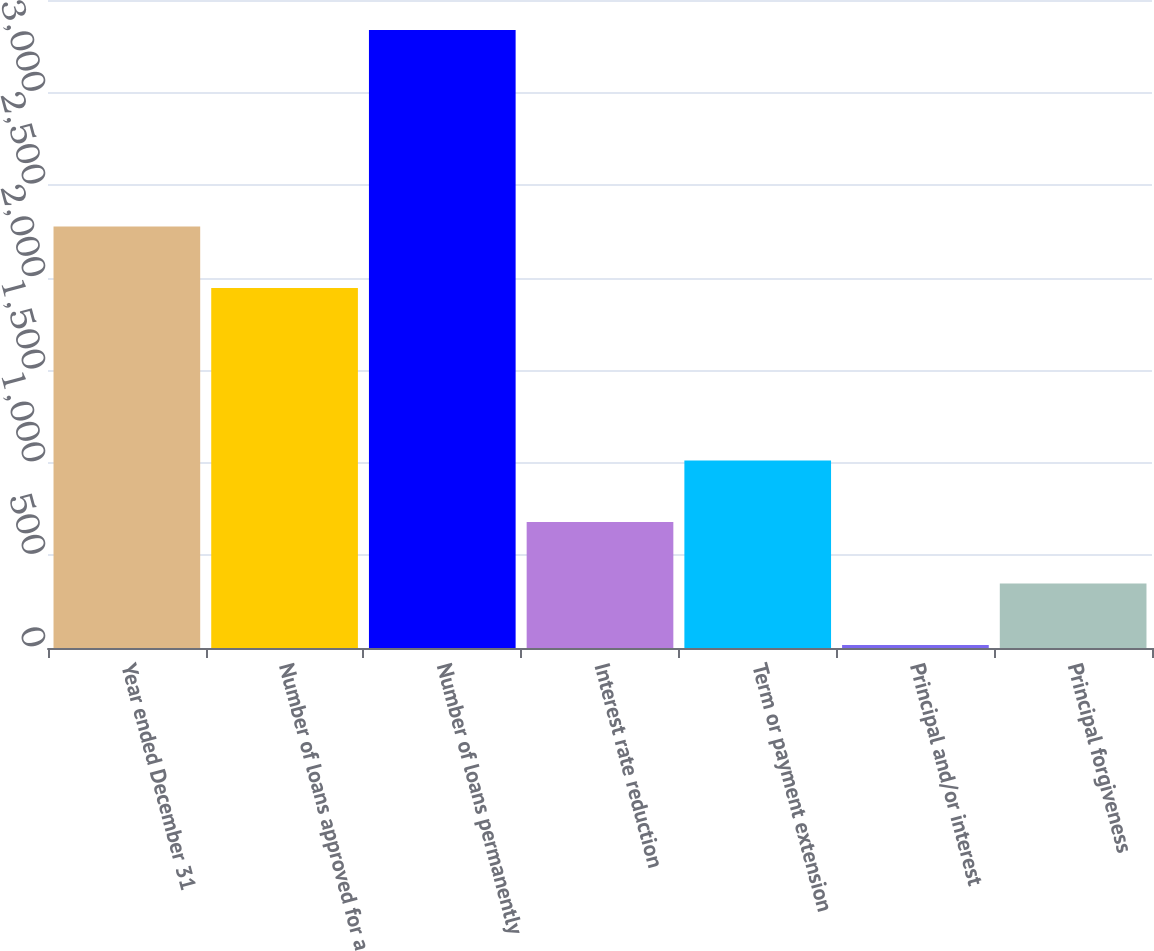Convert chart. <chart><loc_0><loc_0><loc_500><loc_500><bar_chart><fcel>Year ended December 31<fcel>Number of loans approved for a<fcel>Number of loans permanently<fcel>Interest rate reduction<fcel>Term or payment extension<fcel>Principal and/or interest<fcel>Principal forgiveness<nl><fcel>2277.2<fcel>1945<fcel>3338<fcel>680.4<fcel>1012.6<fcel>16<fcel>348.2<nl></chart> 